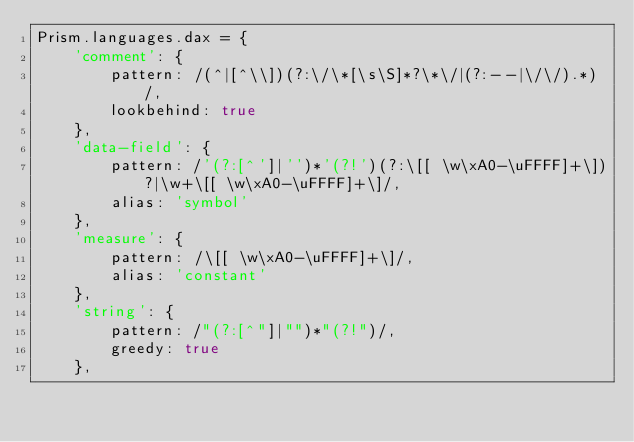Convert code to text. <code><loc_0><loc_0><loc_500><loc_500><_JavaScript_>Prism.languages.dax = {
	'comment': {
		pattern: /(^|[^\\])(?:\/\*[\s\S]*?\*\/|(?:--|\/\/).*)/,
		lookbehind: true
	},
	'data-field': {
		pattern: /'(?:[^']|'')*'(?!')(?:\[[ \w\xA0-\uFFFF]+\])?|\w+\[[ \w\xA0-\uFFFF]+\]/,
		alias: 'symbol'
	},
	'measure': {
		pattern: /\[[ \w\xA0-\uFFFF]+\]/,
		alias: 'constant'
	},
	'string': {
		pattern: /"(?:[^"]|"")*"(?!")/,
		greedy: true
	},</code> 